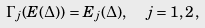Convert formula to latex. <formula><loc_0><loc_0><loc_500><loc_500>\Gamma _ { j } ( E ( \Delta ) ) = E _ { j } ( \Delta ) , \ \ j = 1 , 2 \, ,</formula> 